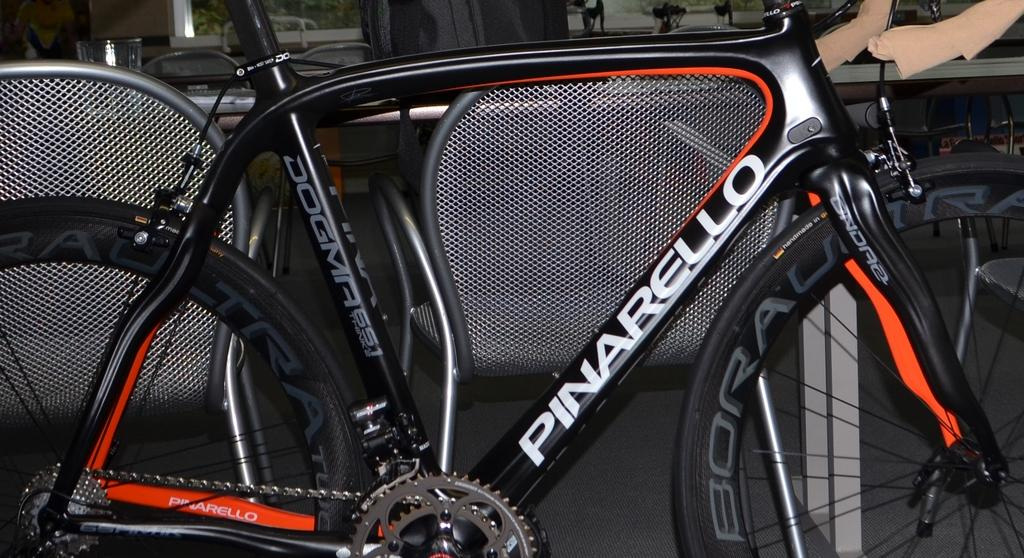What is the main object in the image? There is a bicycle in the image. Can you describe anything in the background of the image? There is a glass in the background of the image. Are there any other objects visible in the background? Yes, there are other unspecified objects in the background of the image. How many experts are present in the image? There are no experts present in the image; it features a bicycle and background objects. What type of beds can be seen in the image? There are no beds present in the image. 